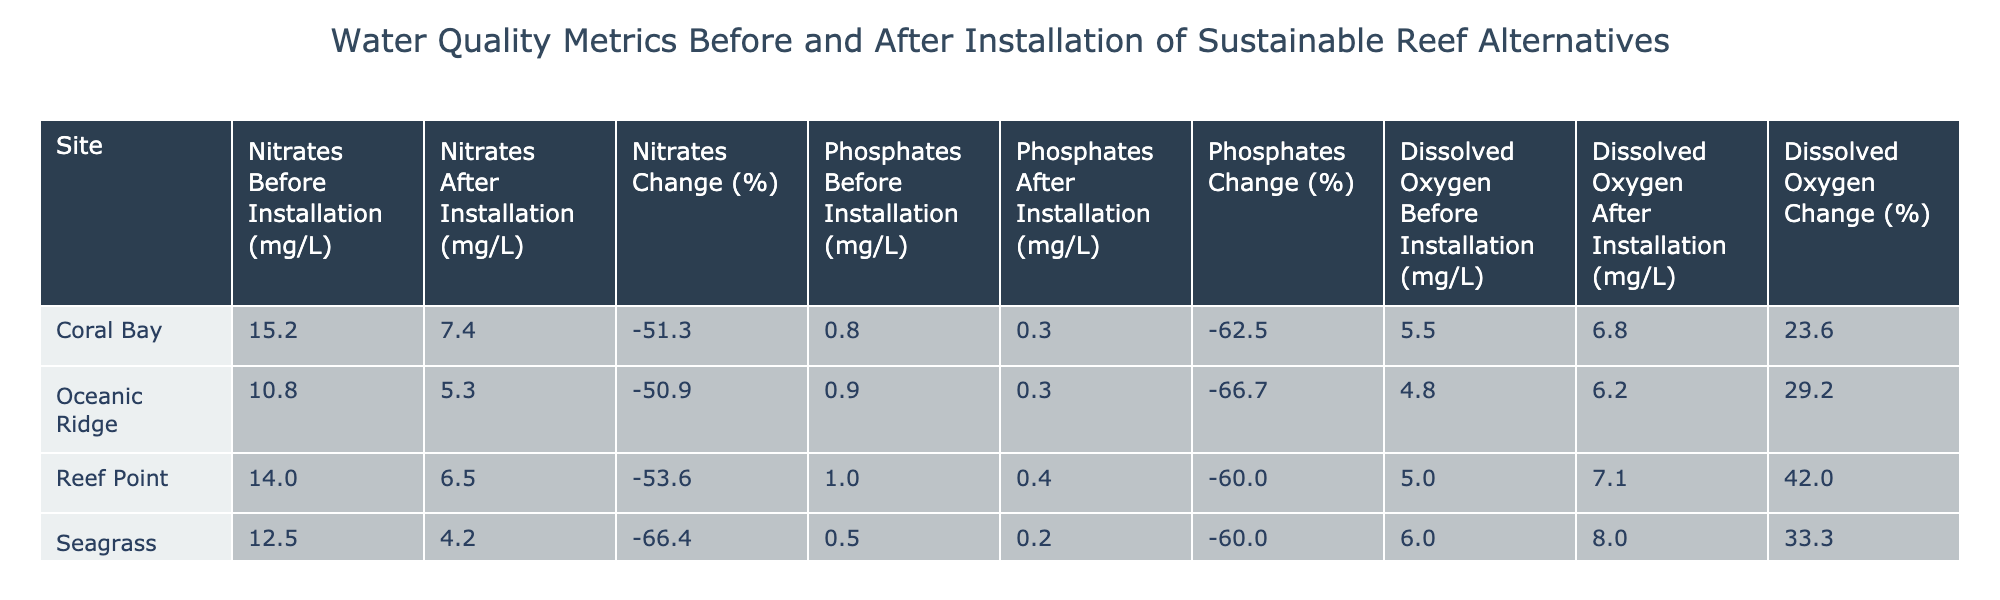What were the nitrates levels in Coral Bay before the installation? The table shows that the nitrates level in Coral Bay before the installation was 15.2 mg/L.
Answer: 15.2 mg/L What is the percent change in phosphates in Reef Point after installation? The table indicates that the phosphates level in Reef Point decreased from 1.0 mg/L to 0.4 mg/L. To find the percent change, we use the formula: ((0.4 - 1.0) / 1.0) * 100, which equals -60%.
Answer: -60% Did Seagrass Haven show an increase or decrease in dissolved oxygen after the installation? The dissolved oxygen level in Seagrass Haven increased from 6.0 mg/L to 8.0 mg/L, indicating an increase after the installation.
Answer: Increase What was the average nitrates level across all sites after installation? First, we list the after installation nitrates values: 7.4 (Coral Bay), 6.5 (Reef Point), 4.2 (Seagrass Haven), and 5.3 (Oceanic Ridge). The sum is 7.4 + 6.5 + 4.2 + 5.3 = 23.4. There are 4 sites, so the average is 23.4 / 4 = 5.85 mg/L.
Answer: 5.85 mg/L Was there any site where phosphates decreased to less than 0.5 mg/L after installation? The table indicates that both Coral Bay (0.3 mg/L) and Reef Point (0.4 mg/L) had phosphates levels below 0.5 mg/L after installation, so the answer is yes.
Answer: Yes What is the difference in dissolved oxygen levels before and after installation at Oceanic Ridge? At Oceanic Ridge, the dissolved oxygen increased from 4.8 mg/L (before) to 6.2 mg/L (after). The difference is calculated by subtracting: 6.2 - 4.8 = 1.4 mg/L.
Answer: 1.4 mg/L 